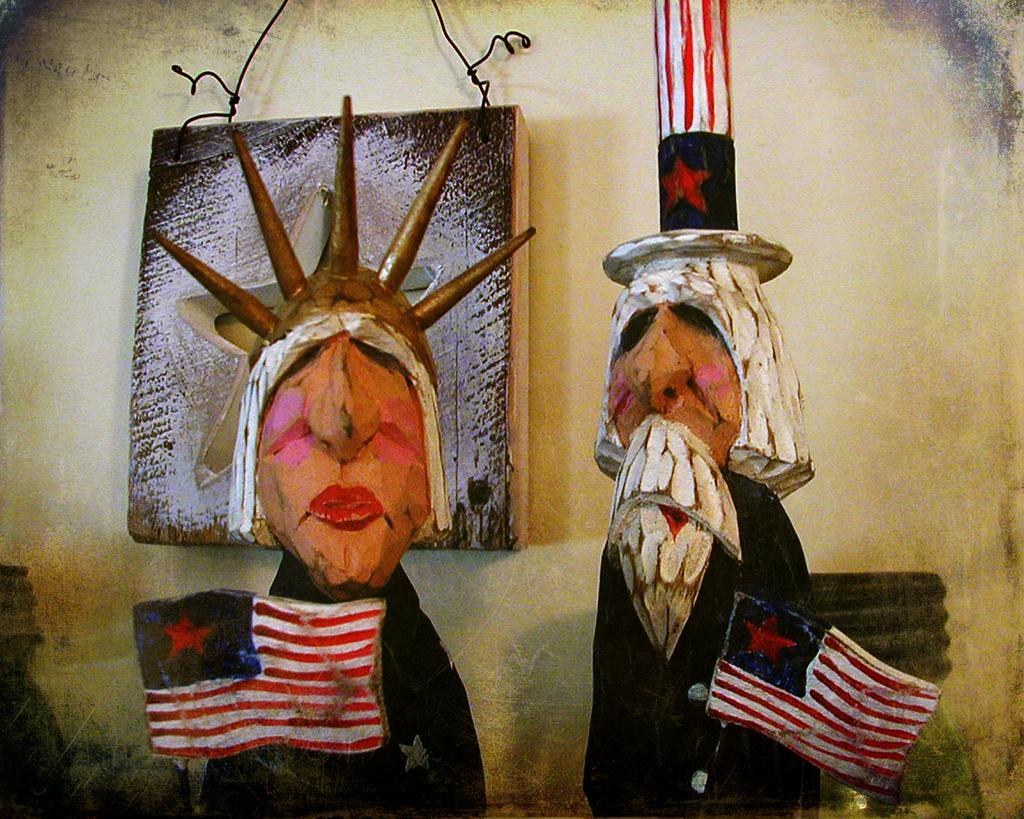How would you summarize this image in a sentence or two? In this picture we can see two wooden carvings, in the background there is a wall, we can see wire here. 